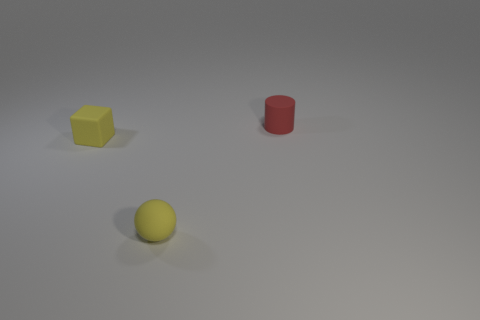What material is the cylinder?
Provide a succinct answer. Rubber. Is there a big cyan cube?
Ensure brevity in your answer.  No. Is the number of tiny blocks to the right of the tiny yellow block the same as the number of gray blocks?
Keep it short and to the point. Yes. How many tiny objects are matte spheres or yellow blocks?
Ensure brevity in your answer.  2. There is a rubber thing that is the same color as the cube; what shape is it?
Keep it short and to the point. Sphere. Is the material of the tiny object in front of the small yellow matte block the same as the yellow cube?
Your answer should be compact. Yes. How many other rubber things have the same shape as the tiny red matte thing?
Make the answer very short. 0. What number of red objects are tiny cubes or tiny rubber cylinders?
Make the answer very short. 1. Are there more objects in front of the small yellow rubber block than big blue objects?
Provide a short and direct response. Yes. What number of other red cylinders are the same size as the red matte cylinder?
Keep it short and to the point. 0. 